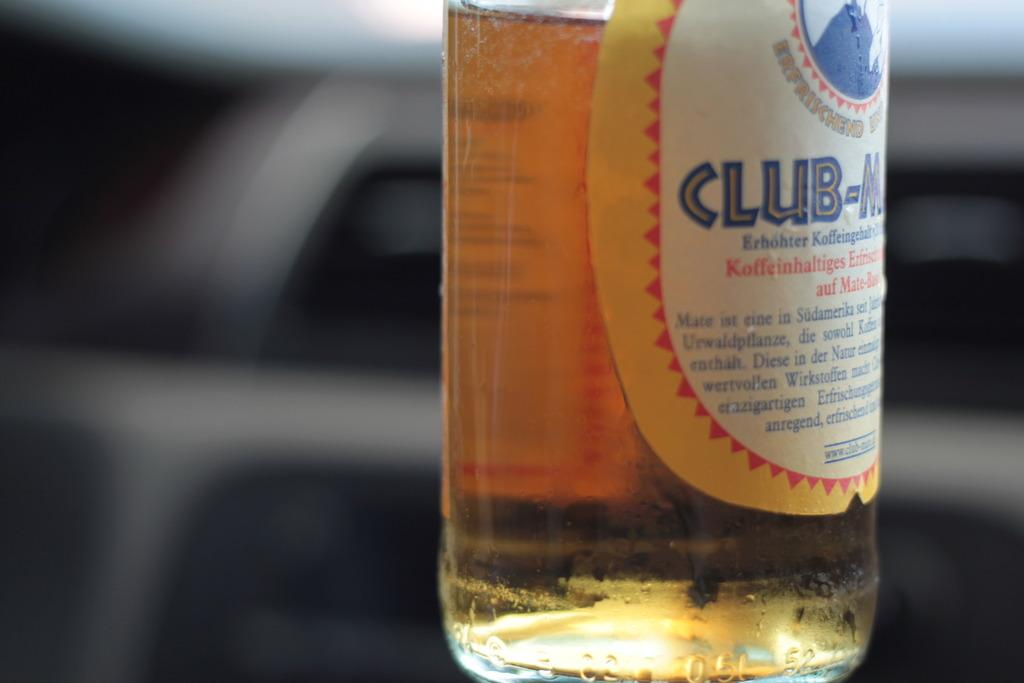<image>
Describe the image concisely. A bottle of beer that can be seen from the brand "club". 